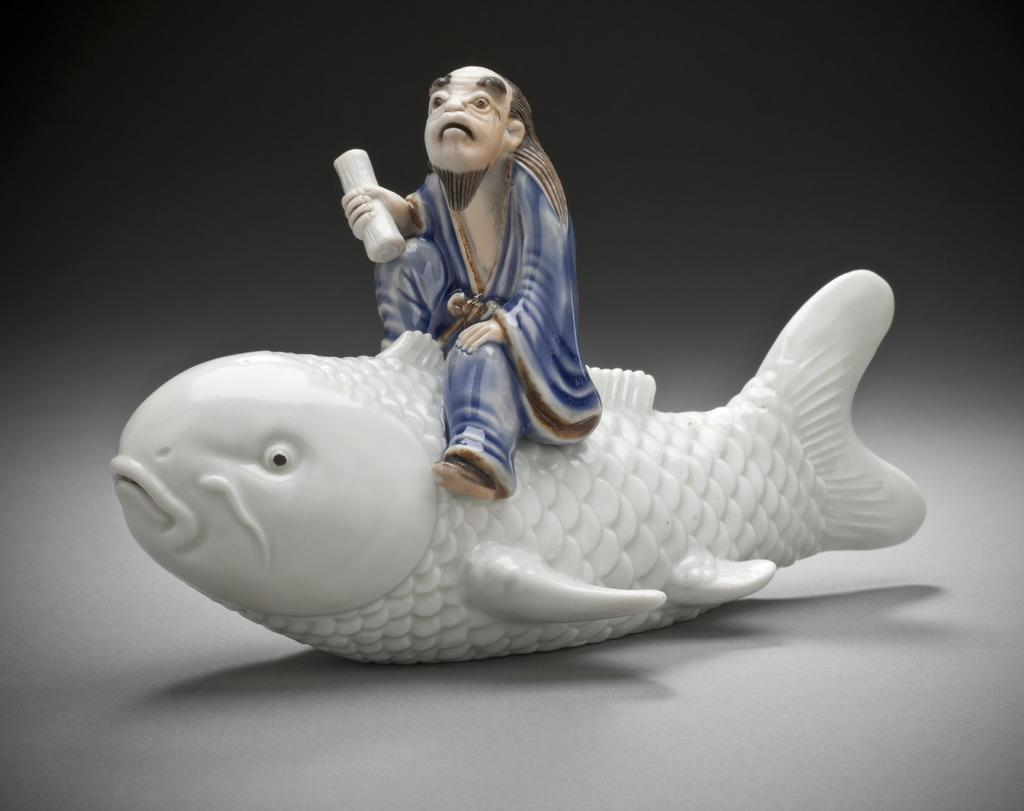What is the main subject of the image? The main subject of the image is a man statue. What is the man statue doing in the image? The man statue is sitting on a fish statue. What can be observed about the background of the image? The background of the image is dark. What type of drawer can be seen in the image? There is no drawer present in the image. Can you hear the drum being played in the image? There is no drum or any sound being played in the image. 